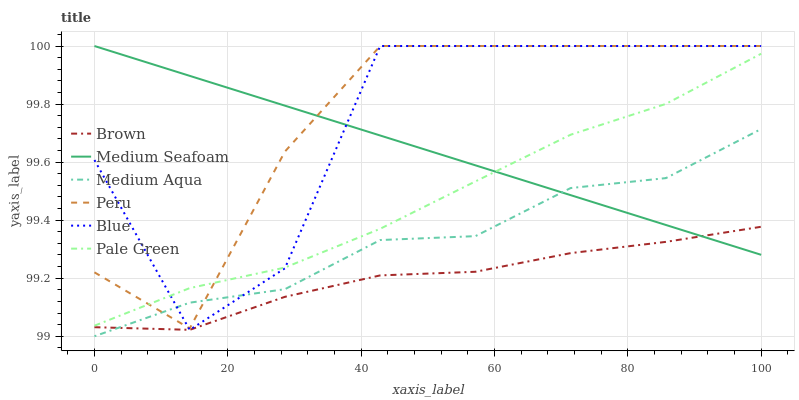Does Brown have the minimum area under the curve?
Answer yes or no. Yes. Does Peru have the maximum area under the curve?
Answer yes or no. Yes. Does Pale Green have the minimum area under the curve?
Answer yes or no. No. Does Pale Green have the maximum area under the curve?
Answer yes or no. No. Is Medium Seafoam the smoothest?
Answer yes or no. Yes. Is Blue the roughest?
Answer yes or no. Yes. Is Brown the smoothest?
Answer yes or no. No. Is Brown the roughest?
Answer yes or no. No. Does Medium Aqua have the lowest value?
Answer yes or no. Yes. Does Brown have the lowest value?
Answer yes or no. No. Does Medium Seafoam have the highest value?
Answer yes or no. Yes. Does Pale Green have the highest value?
Answer yes or no. No. Is Medium Aqua less than Pale Green?
Answer yes or no. Yes. Is Pale Green greater than Brown?
Answer yes or no. Yes. Does Blue intersect Medium Seafoam?
Answer yes or no. Yes. Is Blue less than Medium Seafoam?
Answer yes or no. No. Is Blue greater than Medium Seafoam?
Answer yes or no. No. Does Medium Aqua intersect Pale Green?
Answer yes or no. No. 